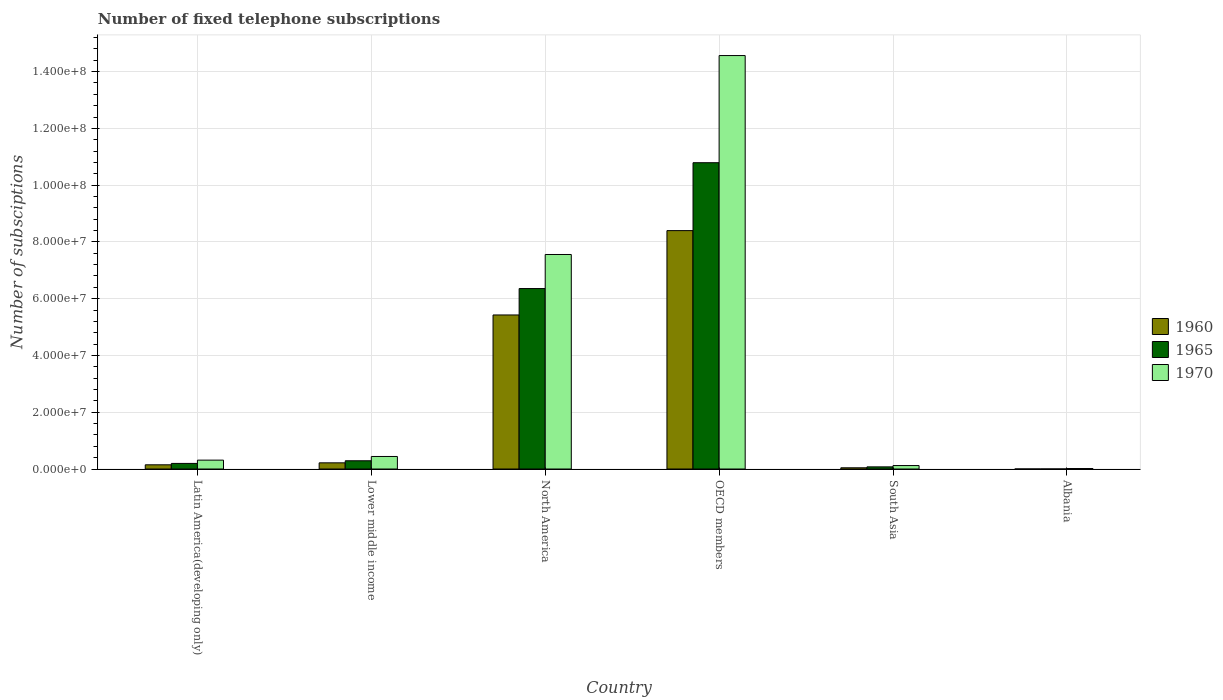How many different coloured bars are there?
Offer a very short reply. 3. How many groups of bars are there?
Make the answer very short. 6. Are the number of bars on each tick of the X-axis equal?
Keep it short and to the point. Yes. How many bars are there on the 1st tick from the left?
Make the answer very short. 3. How many bars are there on the 2nd tick from the right?
Your answer should be very brief. 3. What is the label of the 3rd group of bars from the left?
Your answer should be compact. North America. What is the number of fixed telephone subscriptions in 1970 in Albania?
Ensure brevity in your answer.  1.73e+05. Across all countries, what is the maximum number of fixed telephone subscriptions in 1960?
Ensure brevity in your answer.  8.40e+07. Across all countries, what is the minimum number of fixed telephone subscriptions in 1970?
Your response must be concise. 1.73e+05. In which country was the number of fixed telephone subscriptions in 1960 minimum?
Provide a succinct answer. Albania. What is the total number of fixed telephone subscriptions in 1965 in the graph?
Make the answer very short. 1.77e+08. What is the difference between the number of fixed telephone subscriptions in 1965 in Albania and that in South Asia?
Ensure brevity in your answer.  -7.43e+05. What is the difference between the number of fixed telephone subscriptions in 1960 in OECD members and the number of fixed telephone subscriptions in 1970 in Lower middle income?
Ensure brevity in your answer.  7.96e+07. What is the average number of fixed telephone subscriptions in 1965 per country?
Keep it short and to the point. 2.95e+07. What is the difference between the number of fixed telephone subscriptions of/in 1960 and number of fixed telephone subscriptions of/in 1965 in South Asia?
Provide a short and direct response. -3.27e+05. In how many countries, is the number of fixed telephone subscriptions in 1970 greater than 8000000?
Keep it short and to the point. 2. What is the ratio of the number of fixed telephone subscriptions in 1970 in Albania to that in OECD members?
Offer a very short reply. 0. Is the difference between the number of fixed telephone subscriptions in 1960 in Albania and North America greater than the difference between the number of fixed telephone subscriptions in 1965 in Albania and North America?
Provide a succinct answer. Yes. What is the difference between the highest and the second highest number of fixed telephone subscriptions in 1965?
Make the answer very short. -1.05e+08. What is the difference between the highest and the lowest number of fixed telephone subscriptions in 1965?
Make the answer very short. 1.08e+08. What does the 1st bar from the right in Lower middle income represents?
Your answer should be very brief. 1970. Is it the case that in every country, the sum of the number of fixed telephone subscriptions in 1965 and number of fixed telephone subscriptions in 1960 is greater than the number of fixed telephone subscriptions in 1970?
Your answer should be compact. No. Are all the bars in the graph horizontal?
Your answer should be very brief. No. What is the difference between two consecutive major ticks on the Y-axis?
Provide a short and direct response. 2.00e+07. Are the values on the major ticks of Y-axis written in scientific E-notation?
Give a very brief answer. Yes. Does the graph contain any zero values?
Ensure brevity in your answer.  No. Does the graph contain grids?
Give a very brief answer. Yes. What is the title of the graph?
Ensure brevity in your answer.  Number of fixed telephone subscriptions. What is the label or title of the Y-axis?
Ensure brevity in your answer.  Number of subsciptions. What is the Number of subsciptions in 1960 in Latin America(developing only)?
Your answer should be compact. 1.48e+06. What is the Number of subsciptions of 1965 in Latin America(developing only)?
Your answer should be very brief. 1.97e+06. What is the Number of subsciptions in 1970 in Latin America(developing only)?
Provide a short and direct response. 3.13e+06. What is the Number of subsciptions of 1960 in Lower middle income?
Offer a terse response. 2.17e+06. What is the Number of subsciptions of 1965 in Lower middle income?
Your response must be concise. 2.90e+06. What is the Number of subsciptions in 1970 in Lower middle income?
Provide a short and direct response. 4.42e+06. What is the Number of subsciptions in 1960 in North America?
Your response must be concise. 5.43e+07. What is the Number of subsciptions of 1965 in North America?
Your response must be concise. 6.36e+07. What is the Number of subsciptions of 1970 in North America?
Provide a short and direct response. 7.56e+07. What is the Number of subsciptions in 1960 in OECD members?
Your response must be concise. 8.40e+07. What is the Number of subsciptions in 1965 in OECD members?
Provide a succinct answer. 1.08e+08. What is the Number of subsciptions in 1970 in OECD members?
Make the answer very short. 1.46e+08. What is the Number of subsciptions of 1960 in South Asia?
Offer a very short reply. 4.30e+05. What is the Number of subsciptions of 1965 in South Asia?
Give a very brief answer. 7.57e+05. What is the Number of subsciptions in 1970 in South Asia?
Your response must be concise. 1.22e+06. What is the Number of subsciptions of 1960 in Albania?
Make the answer very short. 6845. What is the Number of subsciptions in 1965 in Albania?
Keep it short and to the point. 1.40e+04. What is the Number of subsciptions of 1970 in Albania?
Make the answer very short. 1.73e+05. Across all countries, what is the maximum Number of subsciptions in 1960?
Give a very brief answer. 8.40e+07. Across all countries, what is the maximum Number of subsciptions in 1965?
Your answer should be compact. 1.08e+08. Across all countries, what is the maximum Number of subsciptions of 1970?
Your response must be concise. 1.46e+08. Across all countries, what is the minimum Number of subsciptions in 1960?
Offer a terse response. 6845. Across all countries, what is the minimum Number of subsciptions in 1965?
Offer a terse response. 1.40e+04. Across all countries, what is the minimum Number of subsciptions of 1970?
Give a very brief answer. 1.73e+05. What is the total Number of subsciptions in 1960 in the graph?
Provide a short and direct response. 1.42e+08. What is the total Number of subsciptions of 1965 in the graph?
Offer a terse response. 1.77e+08. What is the total Number of subsciptions of 1970 in the graph?
Make the answer very short. 2.30e+08. What is the difference between the Number of subsciptions of 1960 in Latin America(developing only) and that in Lower middle income?
Provide a succinct answer. -6.92e+05. What is the difference between the Number of subsciptions in 1965 in Latin America(developing only) and that in Lower middle income?
Make the answer very short. -9.30e+05. What is the difference between the Number of subsciptions of 1970 in Latin America(developing only) and that in Lower middle income?
Offer a terse response. -1.29e+06. What is the difference between the Number of subsciptions in 1960 in Latin America(developing only) and that in North America?
Make the answer very short. -5.28e+07. What is the difference between the Number of subsciptions of 1965 in Latin America(developing only) and that in North America?
Keep it short and to the point. -6.16e+07. What is the difference between the Number of subsciptions of 1970 in Latin America(developing only) and that in North America?
Offer a terse response. -7.24e+07. What is the difference between the Number of subsciptions of 1960 in Latin America(developing only) and that in OECD members?
Ensure brevity in your answer.  -8.25e+07. What is the difference between the Number of subsciptions of 1965 in Latin America(developing only) and that in OECD members?
Your answer should be very brief. -1.06e+08. What is the difference between the Number of subsciptions of 1970 in Latin America(developing only) and that in OECD members?
Your answer should be very brief. -1.43e+08. What is the difference between the Number of subsciptions in 1960 in Latin America(developing only) and that in South Asia?
Provide a succinct answer. 1.05e+06. What is the difference between the Number of subsciptions of 1965 in Latin America(developing only) and that in South Asia?
Provide a succinct answer. 1.21e+06. What is the difference between the Number of subsciptions of 1970 in Latin America(developing only) and that in South Asia?
Provide a succinct answer. 1.91e+06. What is the difference between the Number of subsciptions of 1960 in Latin America(developing only) and that in Albania?
Offer a terse response. 1.48e+06. What is the difference between the Number of subsciptions of 1965 in Latin America(developing only) and that in Albania?
Your response must be concise. 1.96e+06. What is the difference between the Number of subsciptions of 1970 in Latin America(developing only) and that in Albania?
Your answer should be compact. 2.95e+06. What is the difference between the Number of subsciptions of 1960 in Lower middle income and that in North America?
Your response must be concise. -5.21e+07. What is the difference between the Number of subsciptions in 1965 in Lower middle income and that in North America?
Your answer should be very brief. -6.07e+07. What is the difference between the Number of subsciptions of 1970 in Lower middle income and that in North America?
Offer a terse response. -7.12e+07. What is the difference between the Number of subsciptions in 1960 in Lower middle income and that in OECD members?
Your response must be concise. -8.18e+07. What is the difference between the Number of subsciptions in 1965 in Lower middle income and that in OECD members?
Your answer should be very brief. -1.05e+08. What is the difference between the Number of subsciptions in 1970 in Lower middle income and that in OECD members?
Offer a terse response. -1.41e+08. What is the difference between the Number of subsciptions in 1960 in Lower middle income and that in South Asia?
Make the answer very short. 1.74e+06. What is the difference between the Number of subsciptions in 1965 in Lower middle income and that in South Asia?
Give a very brief answer. 2.14e+06. What is the difference between the Number of subsciptions in 1970 in Lower middle income and that in South Asia?
Give a very brief answer. 3.20e+06. What is the difference between the Number of subsciptions of 1960 in Lower middle income and that in Albania?
Your response must be concise. 2.17e+06. What is the difference between the Number of subsciptions of 1965 in Lower middle income and that in Albania?
Provide a succinct answer. 2.89e+06. What is the difference between the Number of subsciptions in 1970 in Lower middle income and that in Albania?
Your response must be concise. 4.25e+06. What is the difference between the Number of subsciptions in 1960 in North America and that in OECD members?
Offer a terse response. -2.97e+07. What is the difference between the Number of subsciptions in 1965 in North America and that in OECD members?
Make the answer very short. -4.43e+07. What is the difference between the Number of subsciptions of 1970 in North America and that in OECD members?
Make the answer very short. -7.01e+07. What is the difference between the Number of subsciptions in 1960 in North America and that in South Asia?
Your response must be concise. 5.38e+07. What is the difference between the Number of subsciptions in 1965 in North America and that in South Asia?
Make the answer very short. 6.28e+07. What is the difference between the Number of subsciptions of 1970 in North America and that in South Asia?
Your answer should be compact. 7.43e+07. What is the difference between the Number of subsciptions of 1960 in North America and that in Albania?
Offer a very short reply. 5.43e+07. What is the difference between the Number of subsciptions in 1965 in North America and that in Albania?
Make the answer very short. 6.36e+07. What is the difference between the Number of subsciptions of 1970 in North America and that in Albania?
Your answer should be very brief. 7.54e+07. What is the difference between the Number of subsciptions in 1960 in OECD members and that in South Asia?
Your response must be concise. 8.36e+07. What is the difference between the Number of subsciptions in 1965 in OECD members and that in South Asia?
Provide a short and direct response. 1.07e+08. What is the difference between the Number of subsciptions of 1970 in OECD members and that in South Asia?
Provide a succinct answer. 1.44e+08. What is the difference between the Number of subsciptions in 1960 in OECD members and that in Albania?
Offer a terse response. 8.40e+07. What is the difference between the Number of subsciptions in 1965 in OECD members and that in Albania?
Provide a short and direct response. 1.08e+08. What is the difference between the Number of subsciptions of 1970 in OECD members and that in Albania?
Offer a terse response. 1.45e+08. What is the difference between the Number of subsciptions of 1960 in South Asia and that in Albania?
Keep it short and to the point. 4.23e+05. What is the difference between the Number of subsciptions in 1965 in South Asia and that in Albania?
Make the answer very short. 7.43e+05. What is the difference between the Number of subsciptions of 1970 in South Asia and that in Albania?
Your answer should be very brief. 1.05e+06. What is the difference between the Number of subsciptions in 1960 in Latin America(developing only) and the Number of subsciptions in 1965 in Lower middle income?
Provide a short and direct response. -1.42e+06. What is the difference between the Number of subsciptions in 1960 in Latin America(developing only) and the Number of subsciptions in 1970 in Lower middle income?
Ensure brevity in your answer.  -2.94e+06. What is the difference between the Number of subsciptions of 1965 in Latin America(developing only) and the Number of subsciptions of 1970 in Lower middle income?
Provide a short and direct response. -2.45e+06. What is the difference between the Number of subsciptions in 1960 in Latin America(developing only) and the Number of subsciptions in 1965 in North America?
Your answer should be very brief. -6.21e+07. What is the difference between the Number of subsciptions in 1960 in Latin America(developing only) and the Number of subsciptions in 1970 in North America?
Keep it short and to the point. -7.41e+07. What is the difference between the Number of subsciptions in 1965 in Latin America(developing only) and the Number of subsciptions in 1970 in North America?
Provide a short and direct response. -7.36e+07. What is the difference between the Number of subsciptions in 1960 in Latin America(developing only) and the Number of subsciptions in 1965 in OECD members?
Your response must be concise. -1.06e+08. What is the difference between the Number of subsciptions in 1960 in Latin America(developing only) and the Number of subsciptions in 1970 in OECD members?
Make the answer very short. -1.44e+08. What is the difference between the Number of subsciptions of 1965 in Latin America(developing only) and the Number of subsciptions of 1970 in OECD members?
Your response must be concise. -1.44e+08. What is the difference between the Number of subsciptions of 1960 in Latin America(developing only) and the Number of subsciptions of 1965 in South Asia?
Your answer should be compact. 7.25e+05. What is the difference between the Number of subsciptions in 1960 in Latin America(developing only) and the Number of subsciptions in 1970 in South Asia?
Make the answer very short. 2.62e+05. What is the difference between the Number of subsciptions in 1965 in Latin America(developing only) and the Number of subsciptions in 1970 in South Asia?
Provide a short and direct response. 7.50e+05. What is the difference between the Number of subsciptions in 1960 in Latin America(developing only) and the Number of subsciptions in 1965 in Albania?
Provide a short and direct response. 1.47e+06. What is the difference between the Number of subsciptions in 1960 in Latin America(developing only) and the Number of subsciptions in 1970 in Albania?
Give a very brief answer. 1.31e+06. What is the difference between the Number of subsciptions of 1965 in Latin America(developing only) and the Number of subsciptions of 1970 in Albania?
Keep it short and to the point. 1.80e+06. What is the difference between the Number of subsciptions in 1960 in Lower middle income and the Number of subsciptions in 1965 in North America?
Your response must be concise. -6.14e+07. What is the difference between the Number of subsciptions of 1960 in Lower middle income and the Number of subsciptions of 1970 in North America?
Your answer should be very brief. -7.34e+07. What is the difference between the Number of subsciptions in 1965 in Lower middle income and the Number of subsciptions in 1970 in North America?
Provide a succinct answer. -7.27e+07. What is the difference between the Number of subsciptions of 1960 in Lower middle income and the Number of subsciptions of 1965 in OECD members?
Your response must be concise. -1.06e+08. What is the difference between the Number of subsciptions in 1960 in Lower middle income and the Number of subsciptions in 1970 in OECD members?
Provide a succinct answer. -1.43e+08. What is the difference between the Number of subsciptions in 1965 in Lower middle income and the Number of subsciptions in 1970 in OECD members?
Keep it short and to the point. -1.43e+08. What is the difference between the Number of subsciptions in 1960 in Lower middle income and the Number of subsciptions in 1965 in South Asia?
Offer a very short reply. 1.42e+06. What is the difference between the Number of subsciptions of 1960 in Lower middle income and the Number of subsciptions of 1970 in South Asia?
Your answer should be very brief. 9.54e+05. What is the difference between the Number of subsciptions of 1965 in Lower middle income and the Number of subsciptions of 1970 in South Asia?
Your answer should be very brief. 1.68e+06. What is the difference between the Number of subsciptions in 1960 in Lower middle income and the Number of subsciptions in 1965 in Albania?
Give a very brief answer. 2.16e+06. What is the difference between the Number of subsciptions of 1960 in Lower middle income and the Number of subsciptions of 1970 in Albania?
Keep it short and to the point. 2.00e+06. What is the difference between the Number of subsciptions of 1965 in Lower middle income and the Number of subsciptions of 1970 in Albania?
Your response must be concise. 2.73e+06. What is the difference between the Number of subsciptions of 1960 in North America and the Number of subsciptions of 1965 in OECD members?
Your answer should be very brief. -5.36e+07. What is the difference between the Number of subsciptions of 1960 in North America and the Number of subsciptions of 1970 in OECD members?
Your answer should be very brief. -9.14e+07. What is the difference between the Number of subsciptions in 1965 in North America and the Number of subsciptions in 1970 in OECD members?
Provide a succinct answer. -8.21e+07. What is the difference between the Number of subsciptions in 1960 in North America and the Number of subsciptions in 1965 in South Asia?
Offer a terse response. 5.35e+07. What is the difference between the Number of subsciptions of 1960 in North America and the Number of subsciptions of 1970 in South Asia?
Your answer should be very brief. 5.30e+07. What is the difference between the Number of subsciptions of 1965 in North America and the Number of subsciptions of 1970 in South Asia?
Provide a short and direct response. 6.24e+07. What is the difference between the Number of subsciptions in 1960 in North America and the Number of subsciptions in 1965 in Albania?
Your answer should be very brief. 5.43e+07. What is the difference between the Number of subsciptions in 1960 in North America and the Number of subsciptions in 1970 in Albania?
Give a very brief answer. 5.41e+07. What is the difference between the Number of subsciptions of 1965 in North America and the Number of subsciptions of 1970 in Albania?
Provide a succinct answer. 6.34e+07. What is the difference between the Number of subsciptions in 1960 in OECD members and the Number of subsciptions in 1965 in South Asia?
Give a very brief answer. 8.32e+07. What is the difference between the Number of subsciptions in 1960 in OECD members and the Number of subsciptions in 1970 in South Asia?
Offer a terse response. 8.28e+07. What is the difference between the Number of subsciptions of 1965 in OECD members and the Number of subsciptions of 1970 in South Asia?
Give a very brief answer. 1.07e+08. What is the difference between the Number of subsciptions of 1960 in OECD members and the Number of subsciptions of 1965 in Albania?
Your response must be concise. 8.40e+07. What is the difference between the Number of subsciptions in 1960 in OECD members and the Number of subsciptions in 1970 in Albania?
Give a very brief answer. 8.38e+07. What is the difference between the Number of subsciptions in 1965 in OECD members and the Number of subsciptions in 1970 in Albania?
Give a very brief answer. 1.08e+08. What is the difference between the Number of subsciptions of 1960 in South Asia and the Number of subsciptions of 1965 in Albania?
Give a very brief answer. 4.16e+05. What is the difference between the Number of subsciptions of 1960 in South Asia and the Number of subsciptions of 1970 in Albania?
Offer a very short reply. 2.57e+05. What is the difference between the Number of subsciptions of 1965 in South Asia and the Number of subsciptions of 1970 in Albania?
Provide a succinct answer. 5.84e+05. What is the average Number of subsciptions in 1960 per country?
Offer a very short reply. 2.37e+07. What is the average Number of subsciptions in 1965 per country?
Make the answer very short. 2.95e+07. What is the average Number of subsciptions in 1970 per country?
Offer a terse response. 3.84e+07. What is the difference between the Number of subsciptions in 1960 and Number of subsciptions in 1965 in Latin America(developing only)?
Make the answer very short. -4.88e+05. What is the difference between the Number of subsciptions in 1960 and Number of subsciptions in 1970 in Latin America(developing only)?
Your answer should be very brief. -1.64e+06. What is the difference between the Number of subsciptions in 1965 and Number of subsciptions in 1970 in Latin America(developing only)?
Offer a terse response. -1.16e+06. What is the difference between the Number of subsciptions of 1960 and Number of subsciptions of 1965 in Lower middle income?
Your answer should be compact. -7.27e+05. What is the difference between the Number of subsciptions of 1960 and Number of subsciptions of 1970 in Lower middle income?
Provide a short and direct response. -2.24e+06. What is the difference between the Number of subsciptions in 1965 and Number of subsciptions in 1970 in Lower middle income?
Give a very brief answer. -1.52e+06. What is the difference between the Number of subsciptions of 1960 and Number of subsciptions of 1965 in North America?
Your response must be concise. -9.30e+06. What is the difference between the Number of subsciptions in 1960 and Number of subsciptions in 1970 in North America?
Make the answer very short. -2.13e+07. What is the difference between the Number of subsciptions of 1965 and Number of subsciptions of 1970 in North America?
Offer a very short reply. -1.20e+07. What is the difference between the Number of subsciptions in 1960 and Number of subsciptions in 1965 in OECD members?
Your answer should be compact. -2.39e+07. What is the difference between the Number of subsciptions of 1960 and Number of subsciptions of 1970 in OECD members?
Offer a very short reply. -6.17e+07. What is the difference between the Number of subsciptions of 1965 and Number of subsciptions of 1970 in OECD members?
Keep it short and to the point. -3.78e+07. What is the difference between the Number of subsciptions in 1960 and Number of subsciptions in 1965 in South Asia?
Your response must be concise. -3.27e+05. What is the difference between the Number of subsciptions in 1960 and Number of subsciptions in 1970 in South Asia?
Provide a short and direct response. -7.90e+05. What is the difference between the Number of subsciptions of 1965 and Number of subsciptions of 1970 in South Asia?
Offer a terse response. -4.63e+05. What is the difference between the Number of subsciptions of 1960 and Number of subsciptions of 1965 in Albania?
Your response must be concise. -7146. What is the difference between the Number of subsciptions in 1960 and Number of subsciptions in 1970 in Albania?
Your answer should be compact. -1.66e+05. What is the difference between the Number of subsciptions of 1965 and Number of subsciptions of 1970 in Albania?
Keep it short and to the point. -1.59e+05. What is the ratio of the Number of subsciptions of 1960 in Latin America(developing only) to that in Lower middle income?
Provide a succinct answer. 0.68. What is the ratio of the Number of subsciptions of 1965 in Latin America(developing only) to that in Lower middle income?
Provide a short and direct response. 0.68. What is the ratio of the Number of subsciptions in 1970 in Latin America(developing only) to that in Lower middle income?
Give a very brief answer. 0.71. What is the ratio of the Number of subsciptions in 1960 in Latin America(developing only) to that in North America?
Make the answer very short. 0.03. What is the ratio of the Number of subsciptions in 1965 in Latin America(developing only) to that in North America?
Provide a succinct answer. 0.03. What is the ratio of the Number of subsciptions in 1970 in Latin America(developing only) to that in North America?
Your answer should be very brief. 0.04. What is the ratio of the Number of subsciptions in 1960 in Latin America(developing only) to that in OECD members?
Provide a short and direct response. 0.02. What is the ratio of the Number of subsciptions in 1965 in Latin America(developing only) to that in OECD members?
Your answer should be compact. 0.02. What is the ratio of the Number of subsciptions of 1970 in Latin America(developing only) to that in OECD members?
Your answer should be compact. 0.02. What is the ratio of the Number of subsciptions of 1960 in Latin America(developing only) to that in South Asia?
Your answer should be very brief. 3.45. What is the ratio of the Number of subsciptions of 1965 in Latin America(developing only) to that in South Asia?
Your response must be concise. 2.6. What is the ratio of the Number of subsciptions of 1970 in Latin America(developing only) to that in South Asia?
Provide a succinct answer. 2.56. What is the ratio of the Number of subsciptions of 1960 in Latin America(developing only) to that in Albania?
Ensure brevity in your answer.  216.53. What is the ratio of the Number of subsciptions of 1965 in Latin America(developing only) to that in Albania?
Offer a very short reply. 140.84. What is the ratio of the Number of subsciptions in 1970 in Latin America(developing only) to that in Albania?
Your response must be concise. 18.07. What is the ratio of the Number of subsciptions in 1960 in Lower middle income to that in North America?
Keep it short and to the point. 0.04. What is the ratio of the Number of subsciptions of 1965 in Lower middle income to that in North America?
Your answer should be very brief. 0.05. What is the ratio of the Number of subsciptions of 1970 in Lower middle income to that in North America?
Give a very brief answer. 0.06. What is the ratio of the Number of subsciptions in 1960 in Lower middle income to that in OECD members?
Your response must be concise. 0.03. What is the ratio of the Number of subsciptions of 1965 in Lower middle income to that in OECD members?
Your answer should be compact. 0.03. What is the ratio of the Number of subsciptions of 1970 in Lower middle income to that in OECD members?
Ensure brevity in your answer.  0.03. What is the ratio of the Number of subsciptions of 1960 in Lower middle income to that in South Asia?
Your answer should be compact. 5.06. What is the ratio of the Number of subsciptions of 1965 in Lower middle income to that in South Asia?
Offer a very short reply. 3.83. What is the ratio of the Number of subsciptions of 1970 in Lower middle income to that in South Asia?
Your answer should be very brief. 3.62. What is the ratio of the Number of subsciptions of 1960 in Lower middle income to that in Albania?
Offer a terse response. 317.63. What is the ratio of the Number of subsciptions in 1965 in Lower middle income to that in Albania?
Provide a succinct answer. 207.34. What is the ratio of the Number of subsciptions of 1970 in Lower middle income to that in Albania?
Offer a very short reply. 25.54. What is the ratio of the Number of subsciptions in 1960 in North America to that in OECD members?
Give a very brief answer. 0.65. What is the ratio of the Number of subsciptions of 1965 in North America to that in OECD members?
Keep it short and to the point. 0.59. What is the ratio of the Number of subsciptions of 1970 in North America to that in OECD members?
Ensure brevity in your answer.  0.52. What is the ratio of the Number of subsciptions of 1960 in North America to that in South Asia?
Offer a very short reply. 126.3. What is the ratio of the Number of subsciptions in 1965 in North America to that in South Asia?
Make the answer very short. 84.02. What is the ratio of the Number of subsciptions in 1970 in North America to that in South Asia?
Your answer should be compact. 61.94. What is the ratio of the Number of subsciptions of 1960 in North America to that in Albania?
Your response must be concise. 7927.8. What is the ratio of the Number of subsciptions of 1965 in North America to that in Albania?
Your answer should be very brief. 4543.67. What is the ratio of the Number of subsciptions of 1970 in North America to that in Albania?
Make the answer very short. 436.82. What is the ratio of the Number of subsciptions of 1960 in OECD members to that in South Asia?
Offer a terse response. 195.46. What is the ratio of the Number of subsciptions in 1965 in OECD members to that in South Asia?
Offer a terse response. 142.6. What is the ratio of the Number of subsciptions of 1970 in OECD members to that in South Asia?
Provide a short and direct response. 119.38. What is the ratio of the Number of subsciptions in 1960 in OECD members to that in Albania?
Provide a succinct answer. 1.23e+04. What is the ratio of the Number of subsciptions of 1965 in OECD members to that in Albania?
Give a very brief answer. 7711.94. What is the ratio of the Number of subsciptions in 1970 in OECD members to that in Albania?
Give a very brief answer. 841.91. What is the ratio of the Number of subsciptions of 1960 in South Asia to that in Albania?
Provide a succinct answer. 62.77. What is the ratio of the Number of subsciptions of 1965 in South Asia to that in Albania?
Make the answer very short. 54.08. What is the ratio of the Number of subsciptions of 1970 in South Asia to that in Albania?
Provide a succinct answer. 7.05. What is the difference between the highest and the second highest Number of subsciptions in 1960?
Offer a terse response. 2.97e+07. What is the difference between the highest and the second highest Number of subsciptions in 1965?
Ensure brevity in your answer.  4.43e+07. What is the difference between the highest and the second highest Number of subsciptions in 1970?
Offer a terse response. 7.01e+07. What is the difference between the highest and the lowest Number of subsciptions of 1960?
Offer a very short reply. 8.40e+07. What is the difference between the highest and the lowest Number of subsciptions in 1965?
Ensure brevity in your answer.  1.08e+08. What is the difference between the highest and the lowest Number of subsciptions of 1970?
Your answer should be very brief. 1.45e+08. 